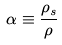Convert formula to latex. <formula><loc_0><loc_0><loc_500><loc_500>\alpha \equiv \frac { \rho _ { s } } { \rho }</formula> 